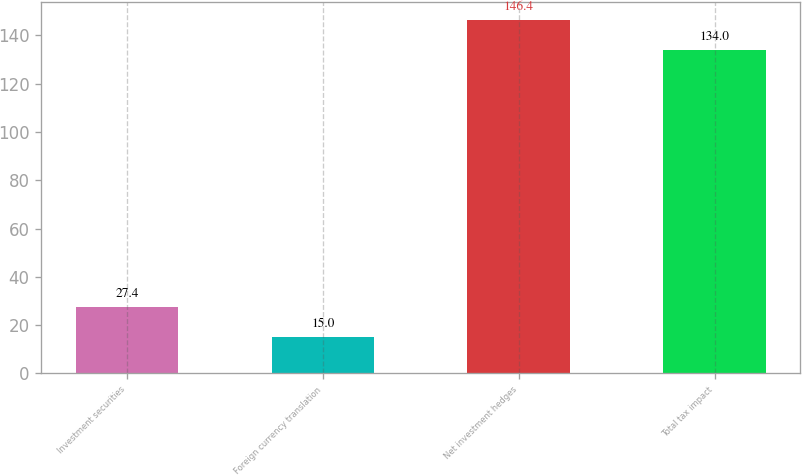Convert chart. <chart><loc_0><loc_0><loc_500><loc_500><bar_chart><fcel>Investment securities<fcel>Foreign currency translation<fcel>Net investment hedges<fcel>Total tax impact<nl><fcel>27.4<fcel>15<fcel>146.4<fcel>134<nl></chart> 